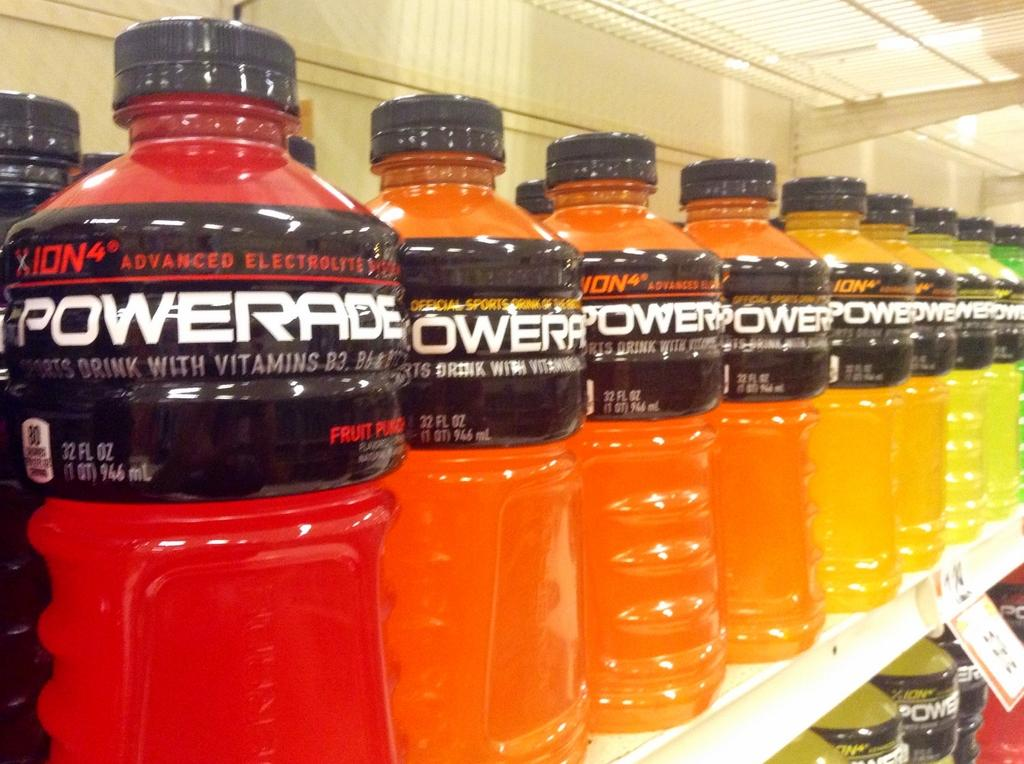<image>
Relay a brief, clear account of the picture shown. A row of bottles of Powerade on the shelf of a grocery store. 